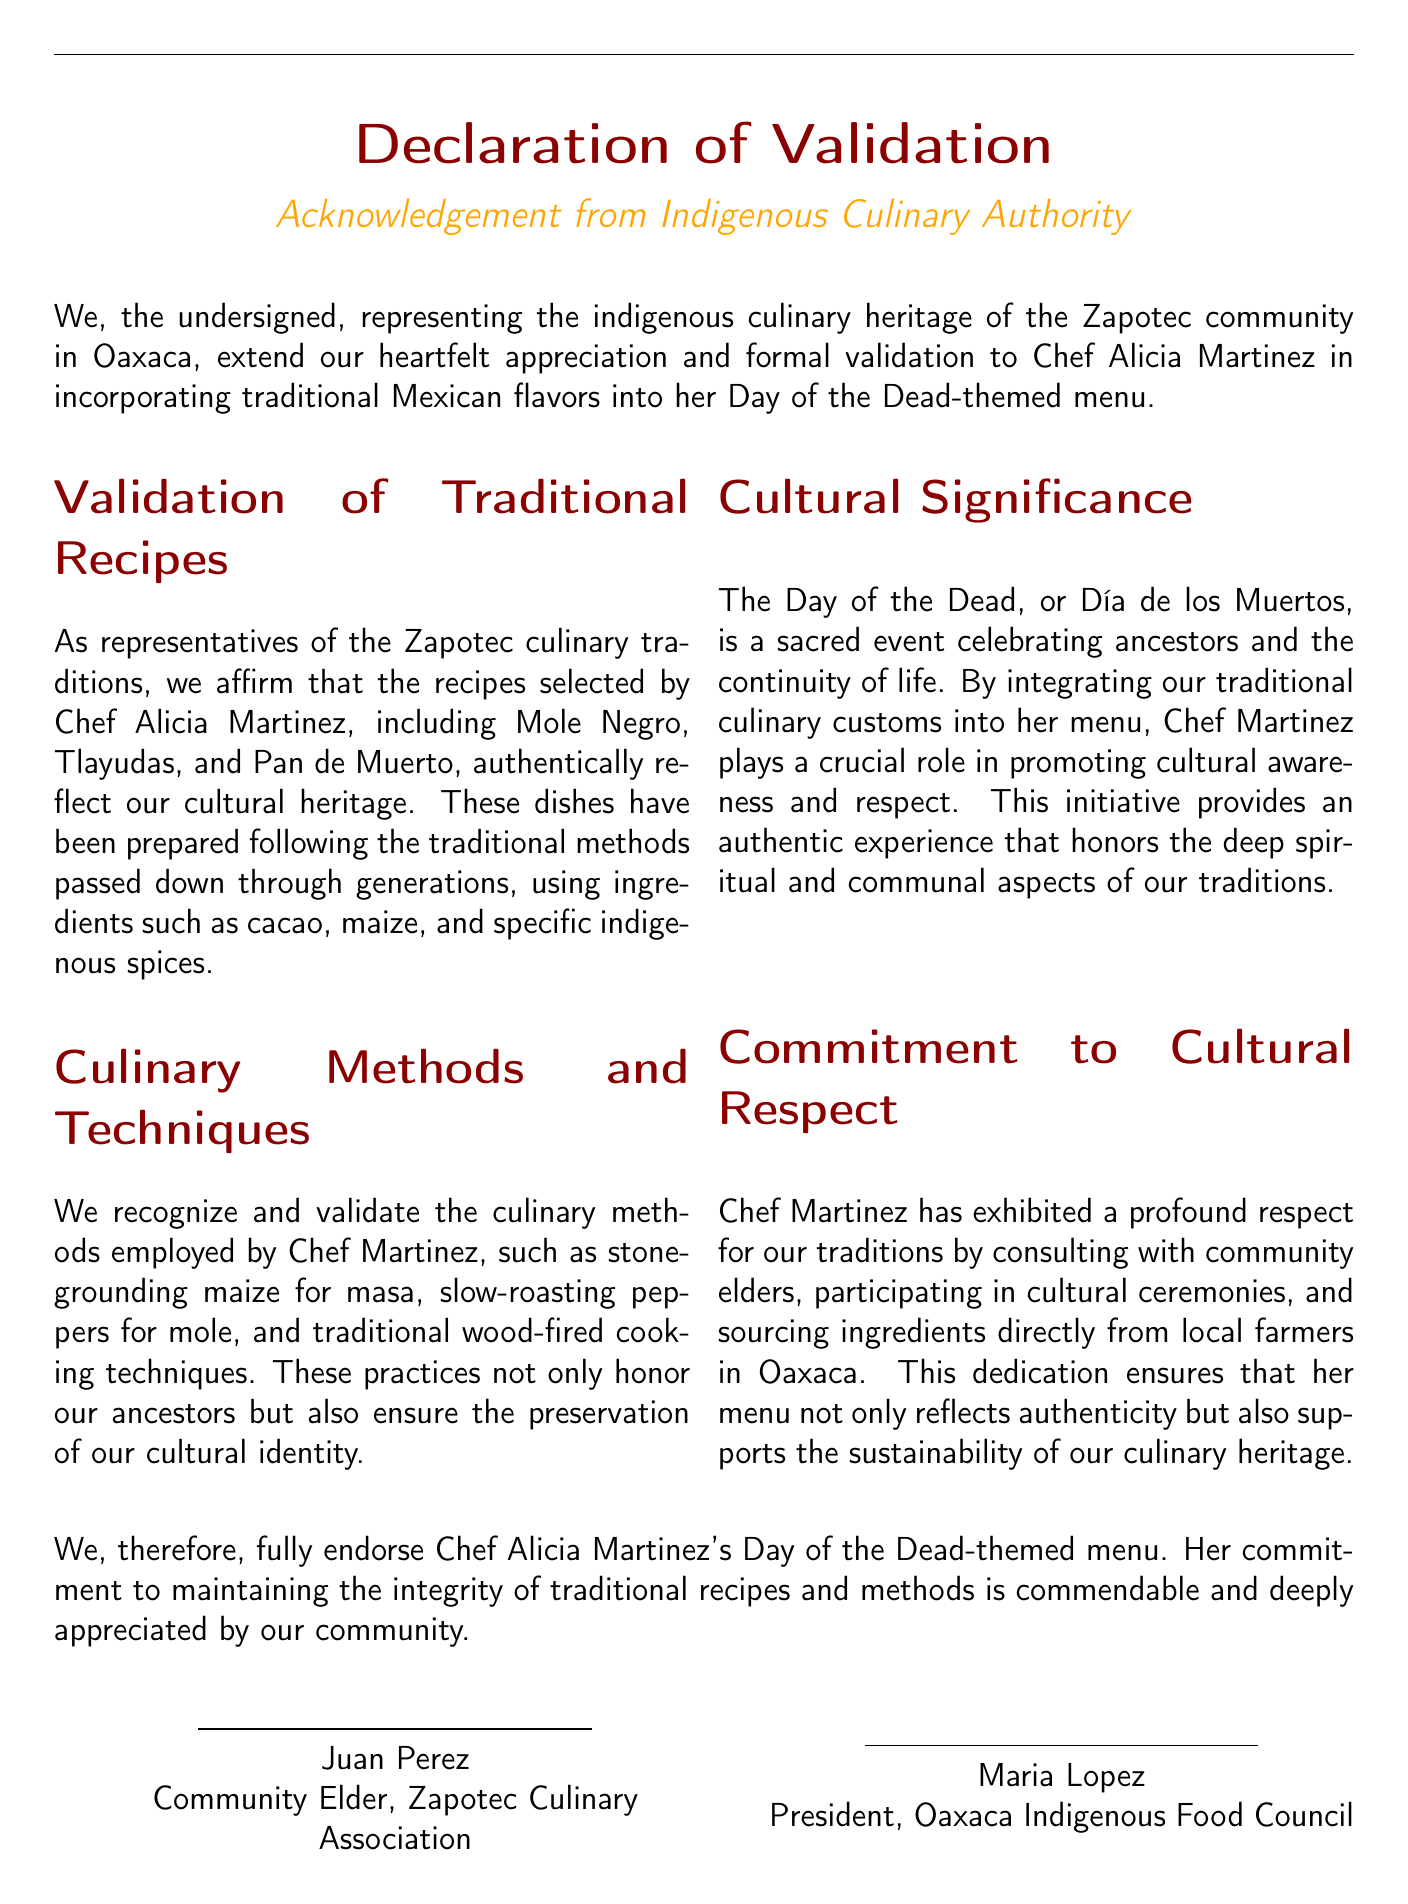What is the title of the document? The title of the document is presented prominently at the top, indicating the nature of the text.
Answer: Declaration of Validation Who is the community elder mentioned in the document? The document provides the name of a community elder who has endorsed the culinary efforts of Chef Alicia Martinez.
Answer: Juan Perez What are the three traditional recipes validated in the document? The document explicitly lists the traditional recipes that have cultural significance within the Zapotec community.
Answer: Mole Negro, Tlayudas, Pan de Muerto What is the significance of the Day of the Dead according to the document? The document highlights the meaning of this celebration, emphasizing its cultural importance within the community.
Answer: Sacred event celebrating ancestors and the continuity of life Who does Chef Alicia Martinez consult with to ensure cultural respect? The document states Chef Martinez's practice of seeking guidance from specific community members to honor traditions.
Answer: Community elders What culinary method involves slow-roasting peppers? The document lists traditional methods, identifying this specific technique that Chef Martinez utilizes.
Answer: Mole What organization is Maria Lopez associated with? The document identifies her role to establish her connection to the indigenous culinary community.
Answer: President, Oaxaca Indigenous Food Council What type of experience does Chef Martinez aim to provide through her menu? The document articulates the type of experience that Chef Martinez's menu intends to deliver, emphasizing authenticity.
Answer: Authentic experience 